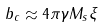Convert formula to latex. <formula><loc_0><loc_0><loc_500><loc_500>b _ { c } \approx 4 \pi \gamma M _ { s } \xi</formula> 